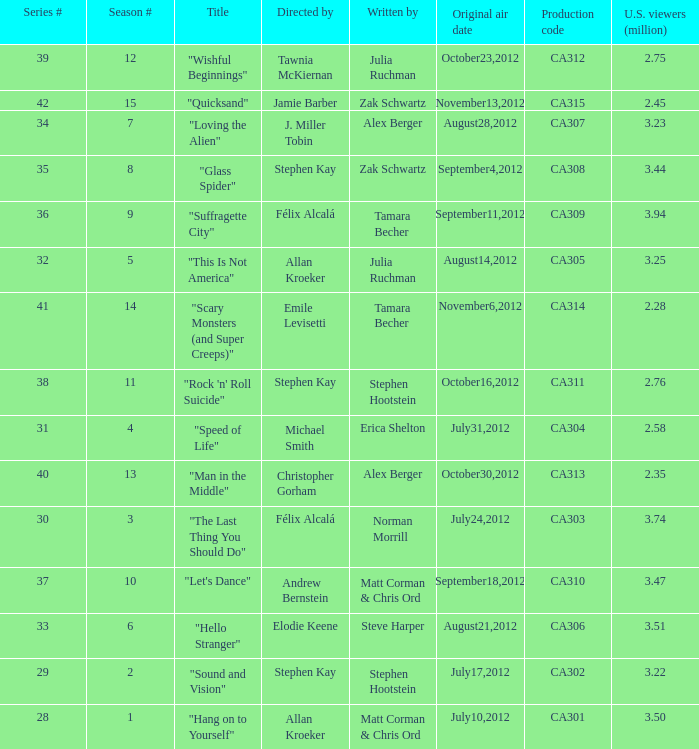Who directed the episode with production code ca303? Félix Alcalá. 